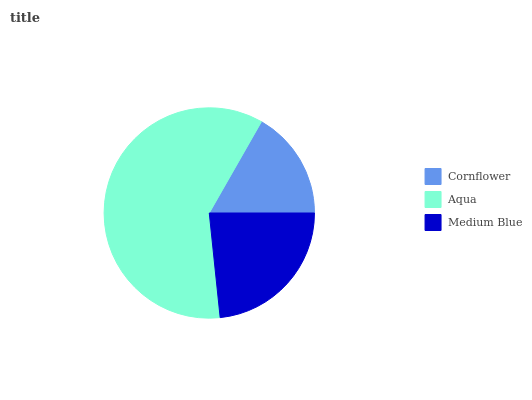Is Cornflower the minimum?
Answer yes or no. Yes. Is Aqua the maximum?
Answer yes or no. Yes. Is Medium Blue the minimum?
Answer yes or no. No. Is Medium Blue the maximum?
Answer yes or no. No. Is Aqua greater than Medium Blue?
Answer yes or no. Yes. Is Medium Blue less than Aqua?
Answer yes or no. Yes. Is Medium Blue greater than Aqua?
Answer yes or no. No. Is Aqua less than Medium Blue?
Answer yes or no. No. Is Medium Blue the high median?
Answer yes or no. Yes. Is Medium Blue the low median?
Answer yes or no. Yes. Is Aqua the high median?
Answer yes or no. No. Is Aqua the low median?
Answer yes or no. No. 